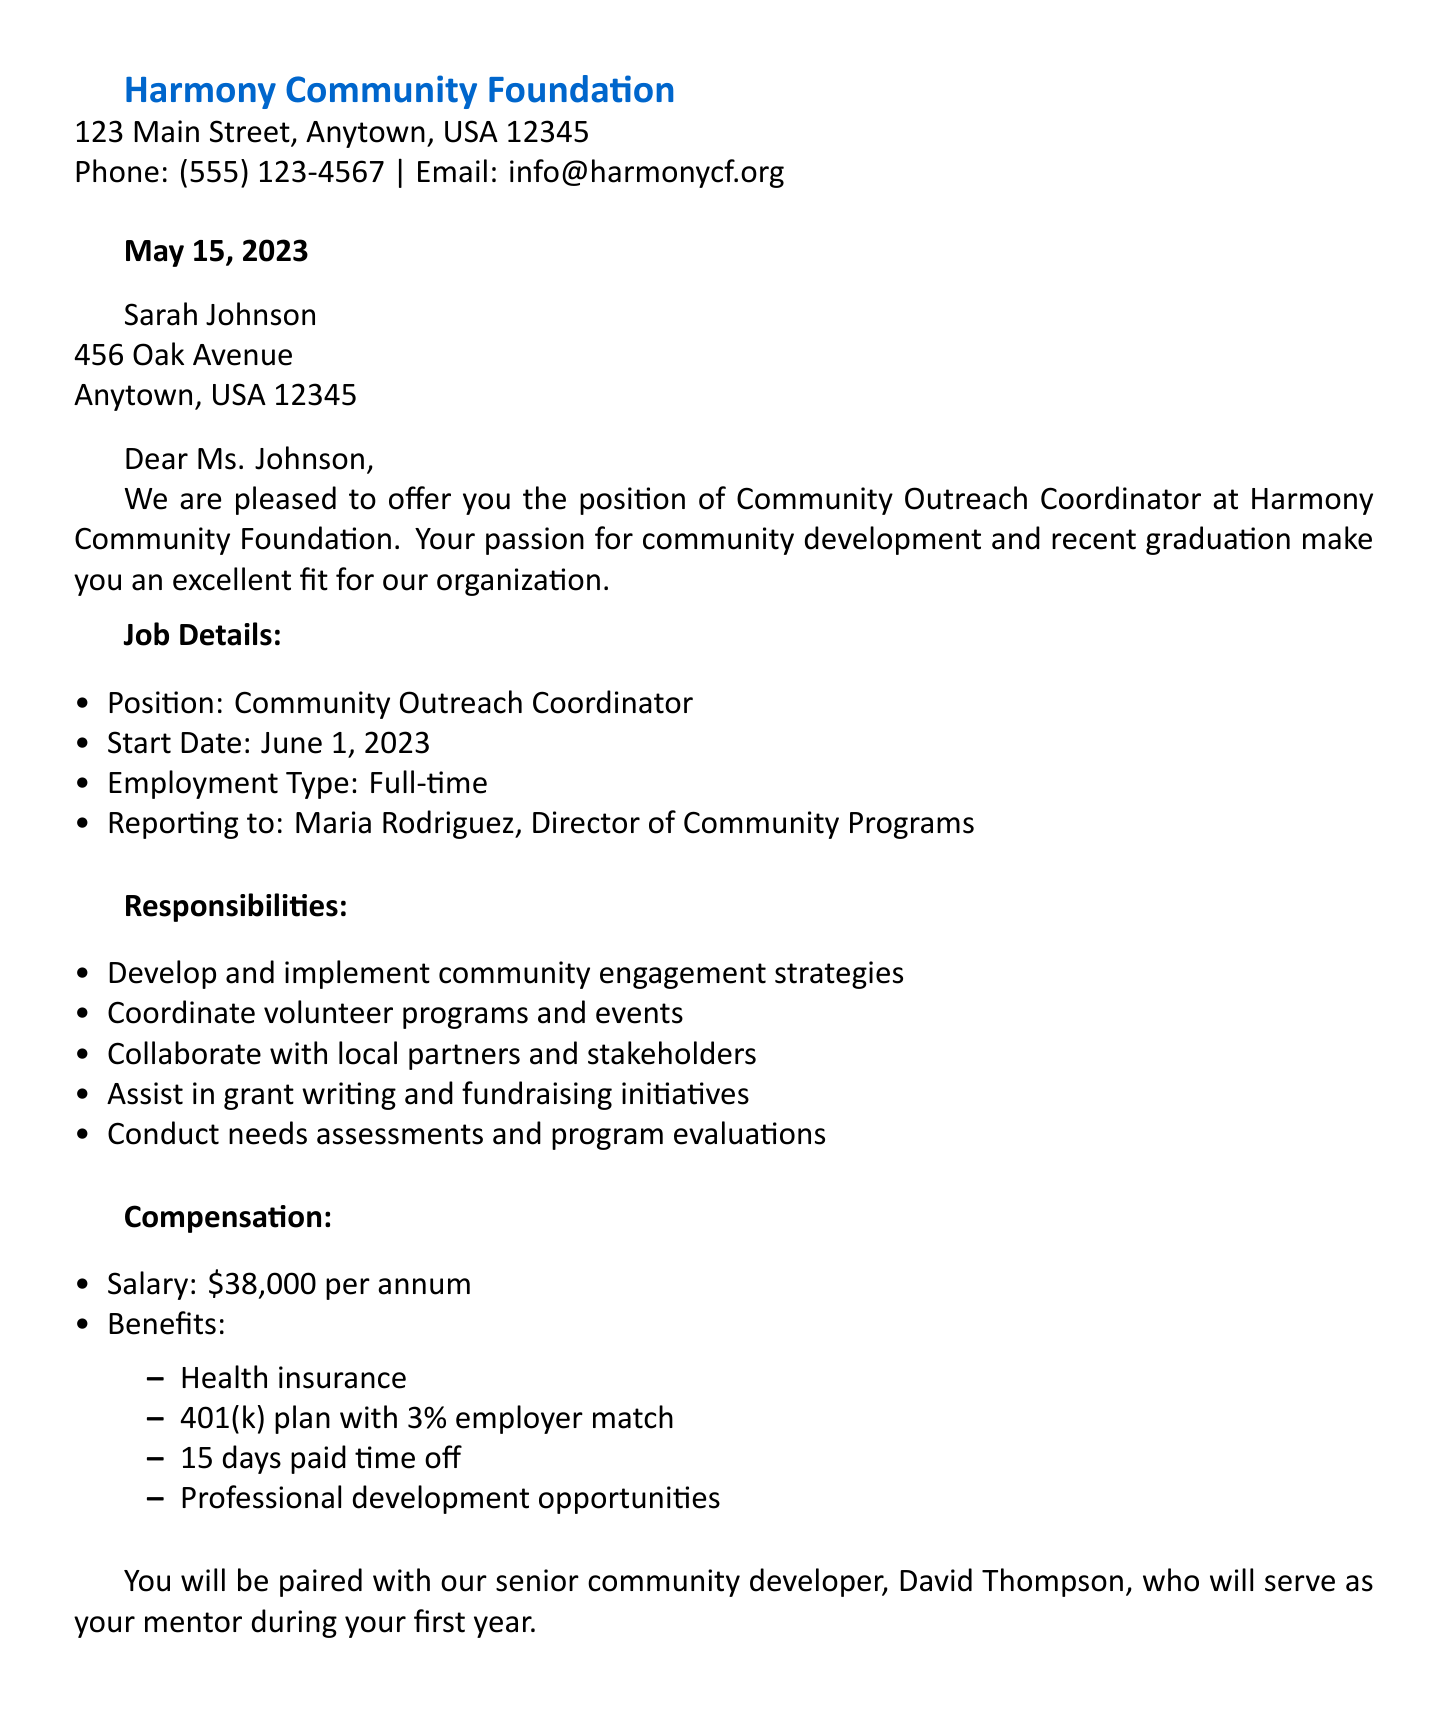What is the name of the organization? The name of the organization is stated at the top of the document.
Answer: Harmony Community Foundation What is the job title offered to Sarah Johnson? The job title is explicitly listed in the job details section of the letter.
Answer: Community Outreach Coordinator When is the start date for the new position? The start date is noted under the job details section.
Answer: June 1, 2023 What is the annual salary for this position? The salary is detailed in the compensation section of the document.
Answer: $38,000 per annum Who will Sarah Johnson report to? The name of the supervisor is mentioned in the job details.
Answer: Maria Rodriguez What benefits are included with the job offer? The benefits are listed under the compensation section in bullet points.
Answer: Health insurance, 401(k) plan with 3% employer match, 15 days paid time off, professional development opportunities What is the deadline for accepting the offer? The deadline is specified in the last paragraph of the letter.
Answer: May 22, 2023 Who is assigned as a mentor for Sarah Johnson? The mentor's name is mentioned in the letter.
Answer: David Thompson What is the employment type for the position? The type of employment is specified in the job details.
Answer: Full-time 